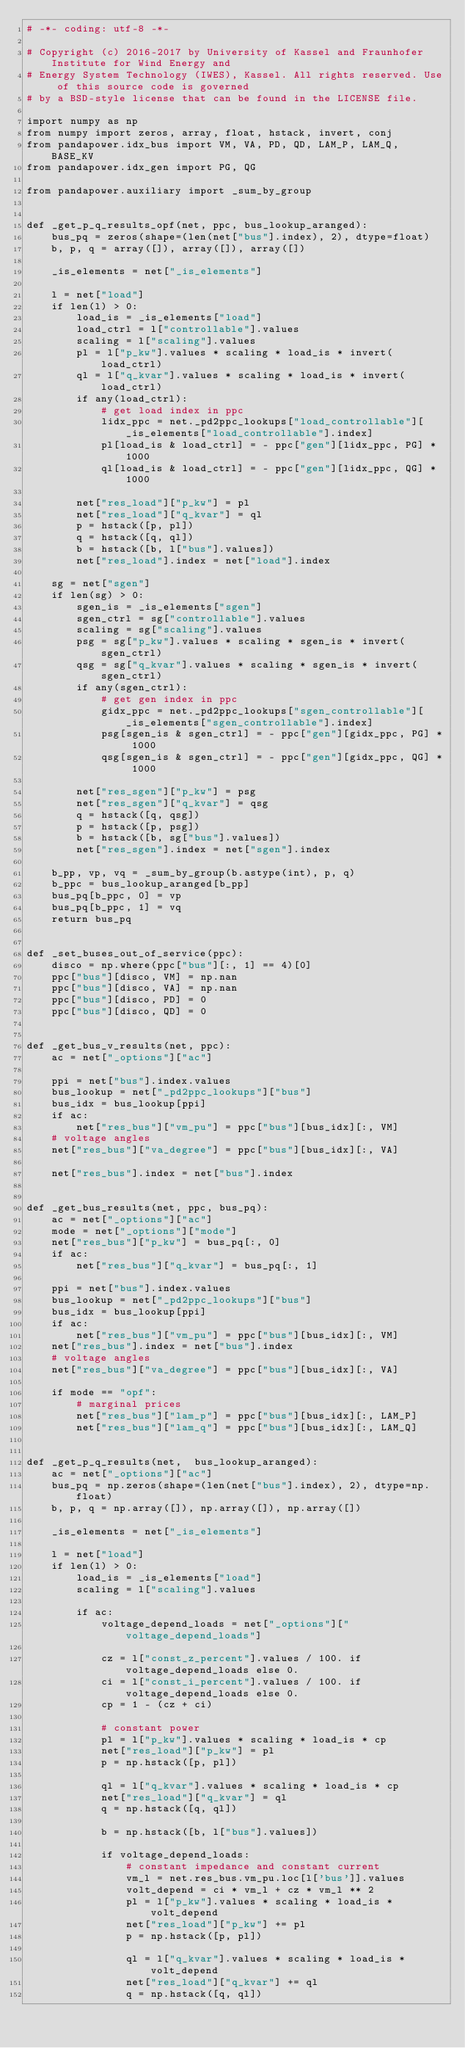Convert code to text. <code><loc_0><loc_0><loc_500><loc_500><_Python_># -*- coding: utf-8 -*-

# Copyright (c) 2016-2017 by University of Kassel and Fraunhofer Institute for Wind Energy and
# Energy System Technology (IWES), Kassel. All rights reserved. Use of this source code is governed
# by a BSD-style license that can be found in the LICENSE file.

import numpy as np
from numpy import zeros, array, float, hstack, invert, conj
from pandapower.idx_bus import VM, VA, PD, QD, LAM_P, LAM_Q, BASE_KV
from pandapower.idx_gen import PG, QG

from pandapower.auxiliary import _sum_by_group


def _get_p_q_results_opf(net, ppc, bus_lookup_aranged):
    bus_pq = zeros(shape=(len(net["bus"].index), 2), dtype=float)
    b, p, q = array([]), array([]), array([])

    _is_elements = net["_is_elements"]

    l = net["load"]
    if len(l) > 0:
        load_is = _is_elements["load"]
        load_ctrl = l["controllable"].values
        scaling = l["scaling"].values
        pl = l["p_kw"].values * scaling * load_is * invert(load_ctrl)
        ql = l["q_kvar"].values * scaling * load_is * invert(load_ctrl)
        if any(load_ctrl):
            # get load index in ppc
            lidx_ppc = net._pd2ppc_lookups["load_controllable"][_is_elements["load_controllable"].index]
            pl[load_is & load_ctrl] = - ppc["gen"][lidx_ppc, PG] * 1000
            ql[load_is & load_ctrl] = - ppc["gen"][lidx_ppc, QG] * 1000

        net["res_load"]["p_kw"] = pl
        net["res_load"]["q_kvar"] = ql
        p = hstack([p, pl])
        q = hstack([q, ql])
        b = hstack([b, l["bus"].values])
        net["res_load"].index = net["load"].index

    sg = net["sgen"]
    if len(sg) > 0:
        sgen_is = _is_elements["sgen"]
        sgen_ctrl = sg["controllable"].values
        scaling = sg["scaling"].values
        psg = sg["p_kw"].values * scaling * sgen_is * invert(sgen_ctrl)
        qsg = sg["q_kvar"].values * scaling * sgen_is * invert(sgen_ctrl)
        if any(sgen_ctrl):
            # get gen index in ppc
            gidx_ppc = net._pd2ppc_lookups["sgen_controllable"][_is_elements["sgen_controllable"].index]
            psg[sgen_is & sgen_ctrl] = - ppc["gen"][gidx_ppc, PG] * 1000
            qsg[sgen_is & sgen_ctrl] = - ppc["gen"][gidx_ppc, QG] * 1000

        net["res_sgen"]["p_kw"] = psg
        net["res_sgen"]["q_kvar"] = qsg
        q = hstack([q, qsg])
        p = hstack([p, psg])
        b = hstack([b, sg["bus"].values])
        net["res_sgen"].index = net["sgen"].index

    b_pp, vp, vq = _sum_by_group(b.astype(int), p, q)
    b_ppc = bus_lookup_aranged[b_pp]
    bus_pq[b_ppc, 0] = vp
    bus_pq[b_ppc, 1] = vq
    return bus_pq


def _set_buses_out_of_service(ppc):
    disco = np.where(ppc["bus"][:, 1] == 4)[0]
    ppc["bus"][disco, VM] = np.nan
    ppc["bus"][disco, VA] = np.nan
    ppc["bus"][disco, PD] = 0
    ppc["bus"][disco, QD] = 0


def _get_bus_v_results(net, ppc):
    ac = net["_options"]["ac"]

    ppi = net["bus"].index.values
    bus_lookup = net["_pd2ppc_lookups"]["bus"]
    bus_idx = bus_lookup[ppi]
    if ac:
        net["res_bus"]["vm_pu"] = ppc["bus"][bus_idx][:, VM]
    # voltage angles
    net["res_bus"]["va_degree"] = ppc["bus"][bus_idx][:, VA]

    net["res_bus"].index = net["bus"].index


def _get_bus_results(net, ppc, bus_pq):
    ac = net["_options"]["ac"]
    mode = net["_options"]["mode"]
    net["res_bus"]["p_kw"] = bus_pq[:, 0]
    if ac:
        net["res_bus"]["q_kvar"] = bus_pq[:, 1]

    ppi = net["bus"].index.values
    bus_lookup = net["_pd2ppc_lookups"]["bus"]
    bus_idx = bus_lookup[ppi]
    if ac:
        net["res_bus"]["vm_pu"] = ppc["bus"][bus_idx][:, VM]
    net["res_bus"].index = net["bus"].index
    # voltage angles
    net["res_bus"]["va_degree"] = ppc["bus"][bus_idx][:, VA]

    if mode == "opf":
        # marginal prices
        net["res_bus"]["lam_p"] = ppc["bus"][bus_idx][:, LAM_P]
        net["res_bus"]["lam_q"] = ppc["bus"][bus_idx][:, LAM_Q]


def _get_p_q_results(net,  bus_lookup_aranged):
    ac = net["_options"]["ac"]
    bus_pq = np.zeros(shape=(len(net["bus"].index), 2), dtype=np.float)
    b, p, q = np.array([]), np.array([]), np.array([])

    _is_elements = net["_is_elements"]

    l = net["load"]
    if len(l) > 0:
        load_is = _is_elements["load"]
        scaling = l["scaling"].values

        if ac:
            voltage_depend_loads = net["_options"]["voltage_depend_loads"]

            cz = l["const_z_percent"].values / 100. if voltage_depend_loads else 0.
            ci = l["const_i_percent"].values / 100. if voltage_depend_loads else 0.
            cp = 1 - (cz + ci)

            # constant power
            pl = l["p_kw"].values * scaling * load_is * cp
            net["res_load"]["p_kw"] = pl
            p = np.hstack([p, pl])

            ql = l["q_kvar"].values * scaling * load_is * cp
            net["res_load"]["q_kvar"] = ql
            q = np.hstack([q, ql])

            b = np.hstack([b, l["bus"].values])

            if voltage_depend_loads:
                # constant impedance and constant current
                vm_l = net.res_bus.vm_pu.loc[l['bus']].values
                volt_depend = ci * vm_l + cz * vm_l ** 2
                pl = l["p_kw"].values * scaling * load_is * volt_depend
                net["res_load"]["p_kw"] += pl
                p = np.hstack([p, pl])

                ql = l["q_kvar"].values * scaling * load_is * volt_depend
                net["res_load"]["q_kvar"] += ql
                q = np.hstack([q, ql])
</code> 